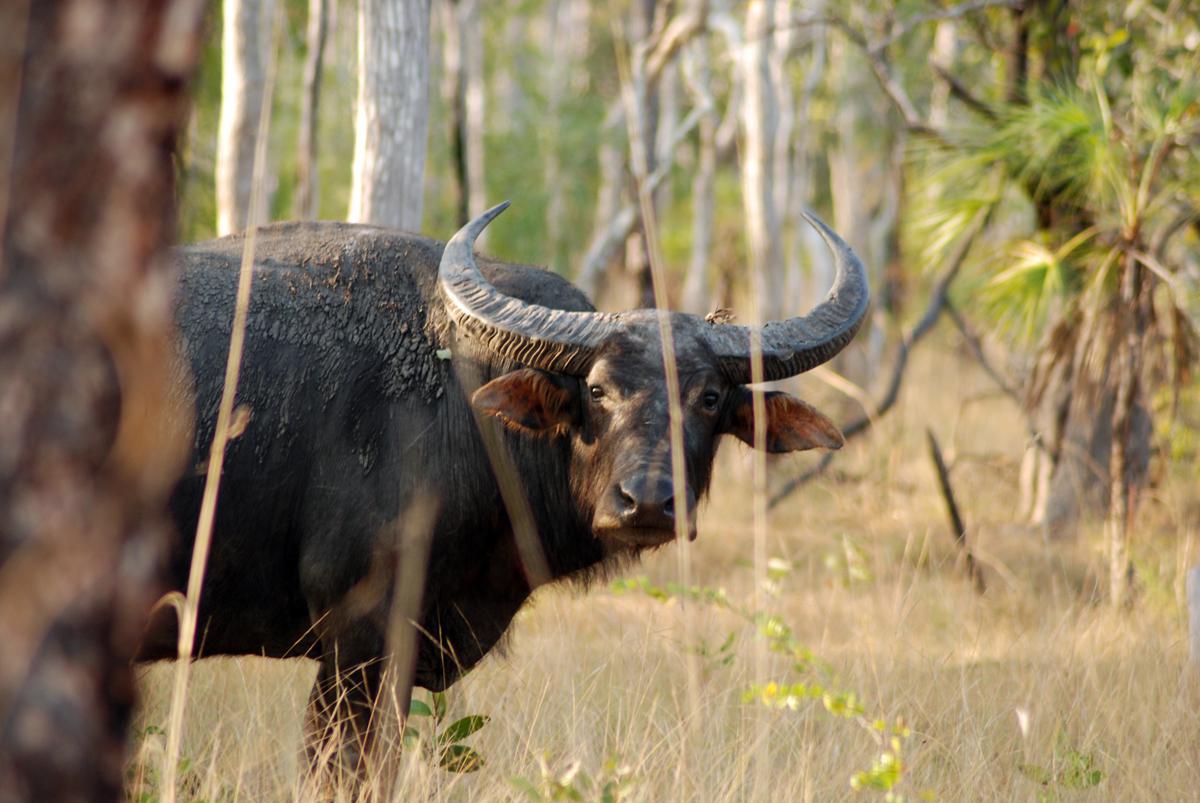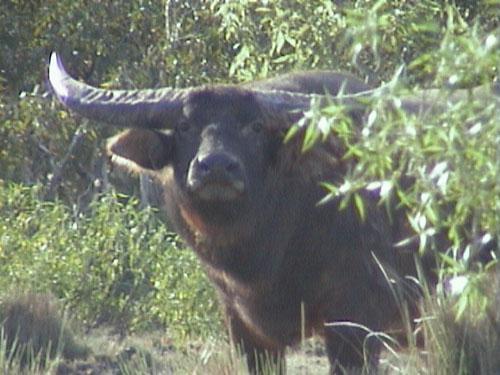The first image is the image on the left, the second image is the image on the right. Examine the images to the left and right. Is the description "There is at least one human in one of the images near a buffalo." accurate? Answer yes or no. No. The first image is the image on the left, the second image is the image on the right. Assess this claim about the two images: "An image contains at least one person behind a dead water buffalo.". Correct or not? Answer yes or no. No. 